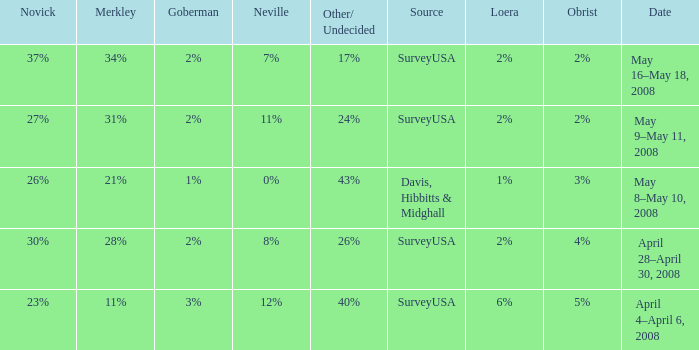Which Goberman has a Date of april 28–april 30, 2008? 2%. 